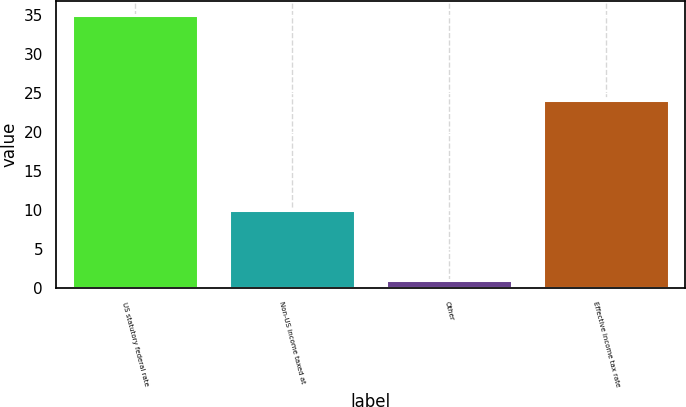<chart> <loc_0><loc_0><loc_500><loc_500><bar_chart><fcel>US statutory federal rate<fcel>Non-US income taxed at<fcel>Other<fcel>Effective income tax rate<nl><fcel>35<fcel>10<fcel>1<fcel>24<nl></chart> 